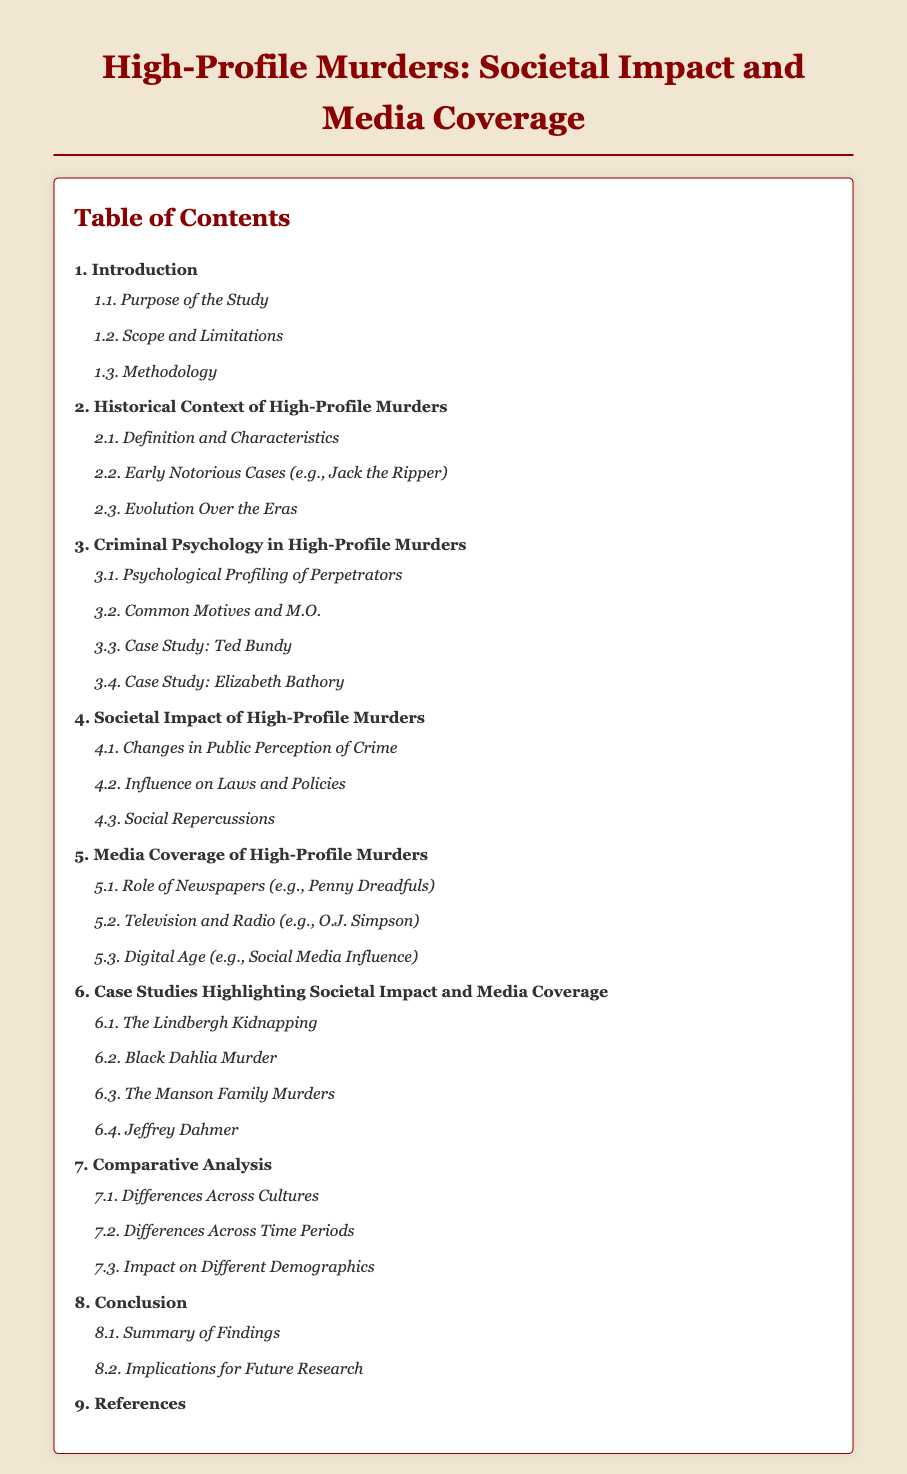What is the title of the document? The title is specified in the head of the document, which is "High-Profile Murders: Societal Impact and Media Coverage."
Answer: High-Profile Murders: Societal Impact and Media Coverage What chapter discusses Criminal Psychology? The table of contents indicates that chapter 3 focuses on Criminal Psychology in High-Profile Murders.
Answer: 3 What is covered in section 4.2? Section 4.2 discusses the influence of high-profile murders on laws and policies.
Answer: Influence on Laws and Policies How many case studies are highlighted in chapter 6? The document lists four specific case studies under chapter 6.
Answer: 4 What is the last chapter of the document? The last chapter is chapter 9, which covers the References section.
Answer: 9 What is the purpose of chapter 4? Chapter 4 focuses on the societal impact of high-profile murders.
Answer: Societal Impact of High-Profile Murders Which subchapter addresses media coverage in the digital age? Subchapter 5.3 in chapter 5 addresses media coverage specifically in the digital age.
Answer: 5.3 What is listed as a notorious early case in 2.2? The document mentions "Jack the Ripper" as an example of an early notorious case.
Answer: Jack the Ripper 